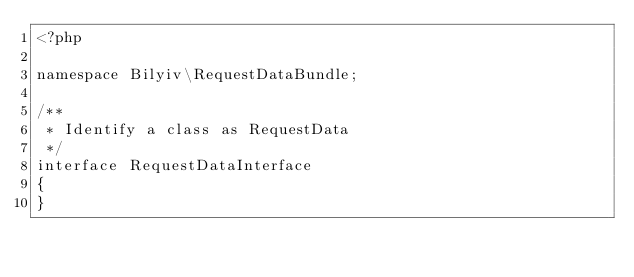<code> <loc_0><loc_0><loc_500><loc_500><_PHP_><?php

namespace Bilyiv\RequestDataBundle;

/**
 * Identify a class as RequestData
 */
interface RequestDataInterface
{
}
</code> 